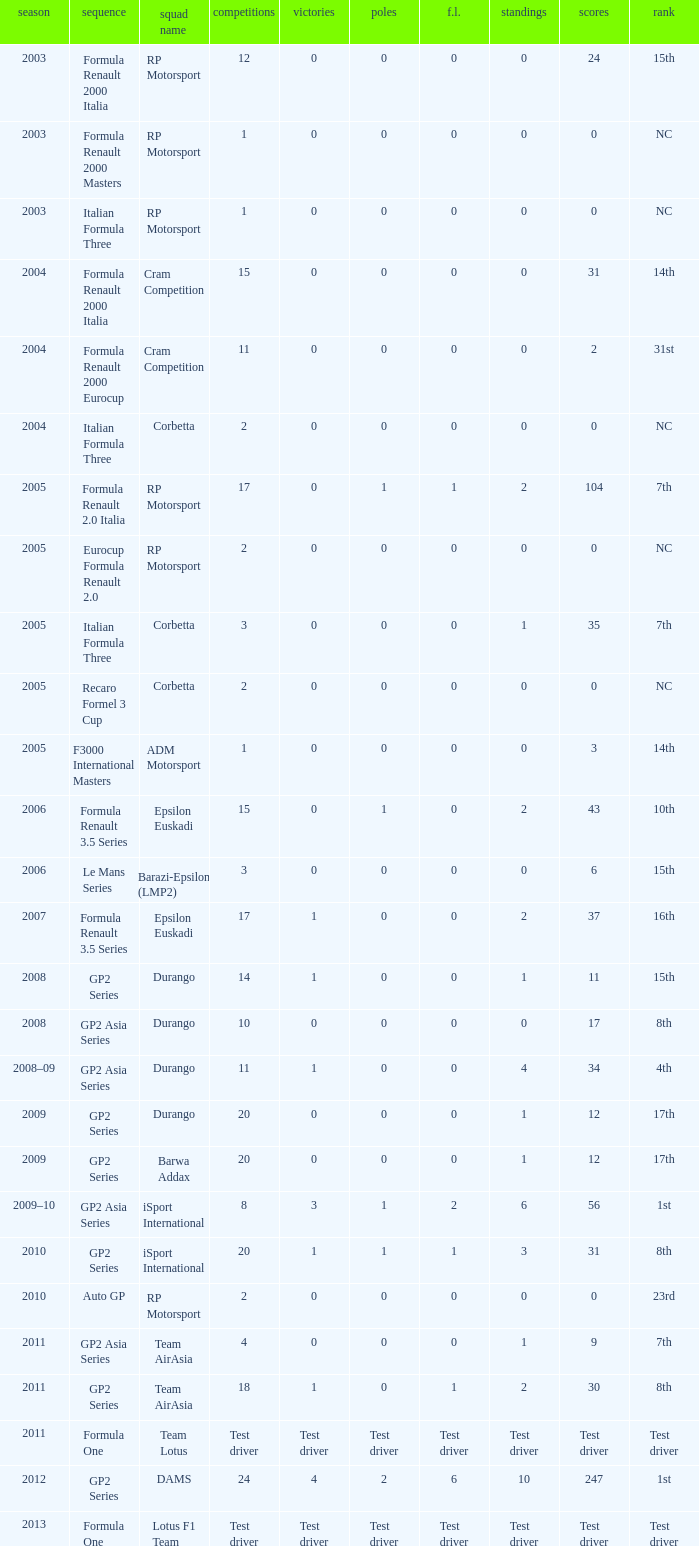What is the number of podiums with 0 wins and 6 points? 0.0. 